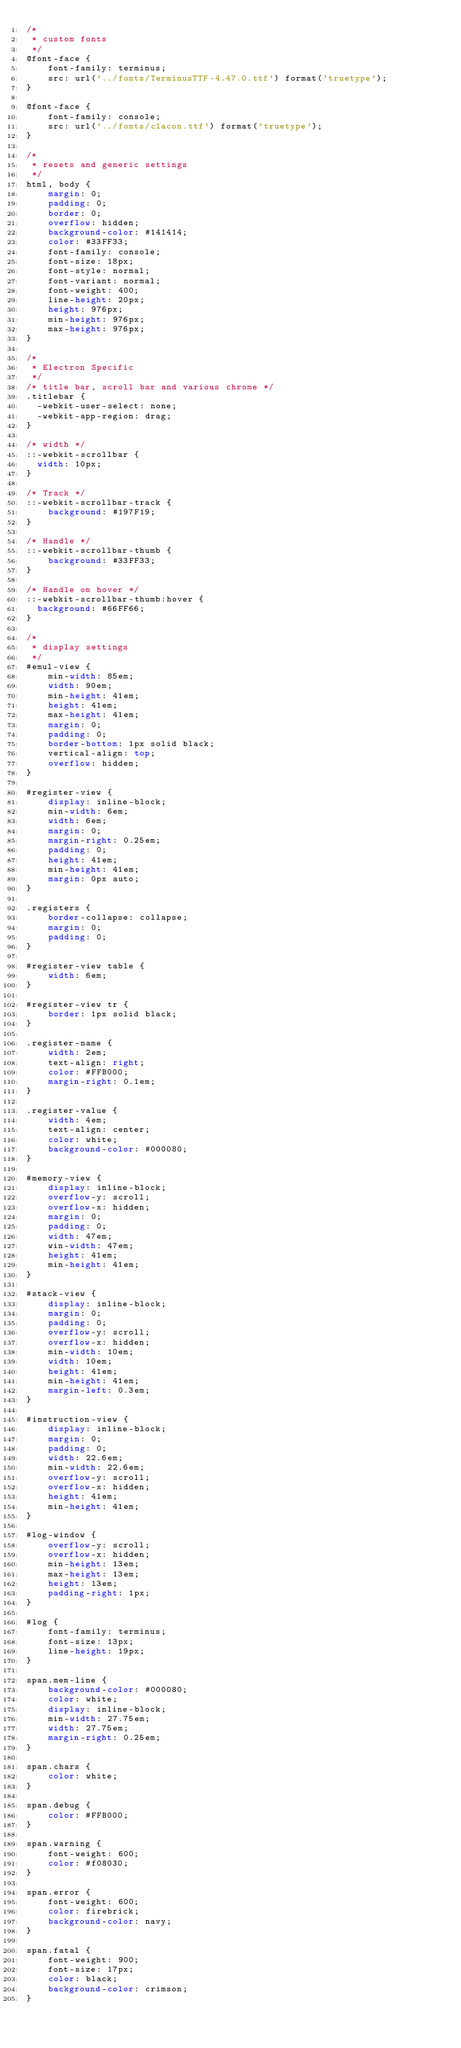<code> <loc_0><loc_0><loc_500><loc_500><_CSS_>/*
 * custom fonts
 */
@font-face {
    font-family: terminus;
    src: url('../fonts/TerminusTTF-4.47.0.ttf') format('truetype');
}

@font-face {
    font-family: console;
    src: url('../fonts/clacon.ttf') format('truetype');
}

/*
 * resets and generic settings
 */
html, body {
    margin: 0;
    padding: 0;
    border: 0;
    overflow: hidden;
    background-color: #141414;
    color: #33FF33;
    font-family: console;
    font-size: 18px;
    font-style: normal;
    font-variant: normal;
    font-weight: 400;
    line-height: 20px;
    height: 976px;
    min-height: 976px;
    max-height: 976px;
}

/*
 * Electron Specific
 */
/* title bar, scroll bar and various chrome */
.titlebar {
  -webkit-user-select: none;
  -webkit-app-region: drag;
}

/* width */
::-webkit-scrollbar {
  width: 10px;
}

/* Track */
::-webkit-scrollbar-track {
    background: #197F19;
}

/* Handle */
::-webkit-scrollbar-thumb {
    background: #33FF33;
}

/* Handle on hover */
::-webkit-scrollbar-thumb:hover {
  background: #66FF66;
}

/*
 * display settings
 */
#emul-view {
    min-width: 85em;
    width: 90em;
    min-height: 41em;
    height: 41em;
    max-height: 41em;
    margin: 0;
    padding: 0;
    border-bottom: 1px solid black;
    vertical-align: top;
    overflow: hidden;
}

#register-view {
    display: inline-block;
    min-width: 6em;
    width: 6em;
    margin: 0;
    margin-right: 0.25em;
    padding: 0;
    height: 41em;
    min-height: 41em;
    margin: 0px auto;
}

.registers {
    border-collapse: collapse;
    margin: 0;
    padding: 0;
}

#register-view table {
    width: 6em;
}

#register-view tr {
    border: 1px solid black;
}

.register-name {
    width: 2em;
    text-align: right;
    color: #FFB000;
    margin-right: 0.1em;
}

.register-value {
    width: 4em;
    text-align: center;
    color: white;
    background-color: #000080;
}

#memory-view {
    display: inline-block;
    overflow-y: scroll;
    overflow-x: hidden;
    margin: 0;
    padding: 0;
    width: 47em;
    win-width: 47em;
    height: 41em;
    min-height: 41em;
}

#stack-view {
    display: inline-block;
    margin: 0;
    padding: 0;
    overflow-y: scroll;
    overflow-x: hidden;
    min-width: 10em;
    width: 10em;
    height: 41em;
    min-height: 41em;
    margin-left: 0.3em;
}

#instruction-view {
    display: inline-block;
    margin: 0;
    padding: 0;
    width: 22.6em;
    min-width: 22.6em;
    overflow-y: scroll;
    overflow-x: hidden;
    height: 41em;
    min-height: 41em;
}

#log-window {
    overflow-y: scroll;
    overflow-x: hidden;
    min-height: 13em;
    max-height: 13em;
    height: 13em;
    padding-right: 1px;
}

#log {
    font-family: terminus;
    font-size: 13px;
    line-height: 19px;
}

span.mem-line {
    background-color: #000080;
    color: white;
    display: inline-block;
    min-width: 27.75em;
    width: 27.75em;
    margin-right: 0.25em;
}

span.chars {
    color: white;
}

span.debug {
    color: #FFB000;
}

span.warning {
    font-weight: 600;
    color: #f08030;
}

span.error {
    font-weight: 600;
    color: firebrick;
    background-color: navy;
}

span.fatal {
    font-weight: 900;
    font-size: 17px;
    color: black;
    background-color: crimson;
}
</code> 